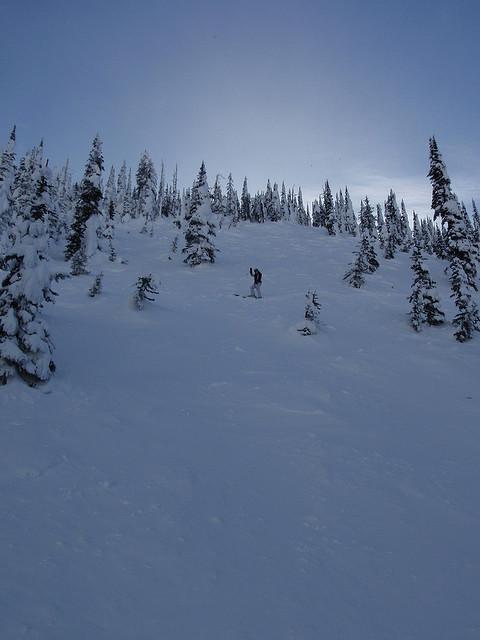What color is the snow?
Short answer required. White. What is the fire hydrant buried in?
Concise answer only. Snow. What objects on the hill should the skier avoid?
Write a very short answer. Trees. Is the person skiing?
Concise answer only. Yes. How cold is it outside?
Concise answer only. Cold. Is this fresh undisturbed snow?
Keep it brief. Yes. Which direction is the sun in the photo?
Quick response, please. West. 